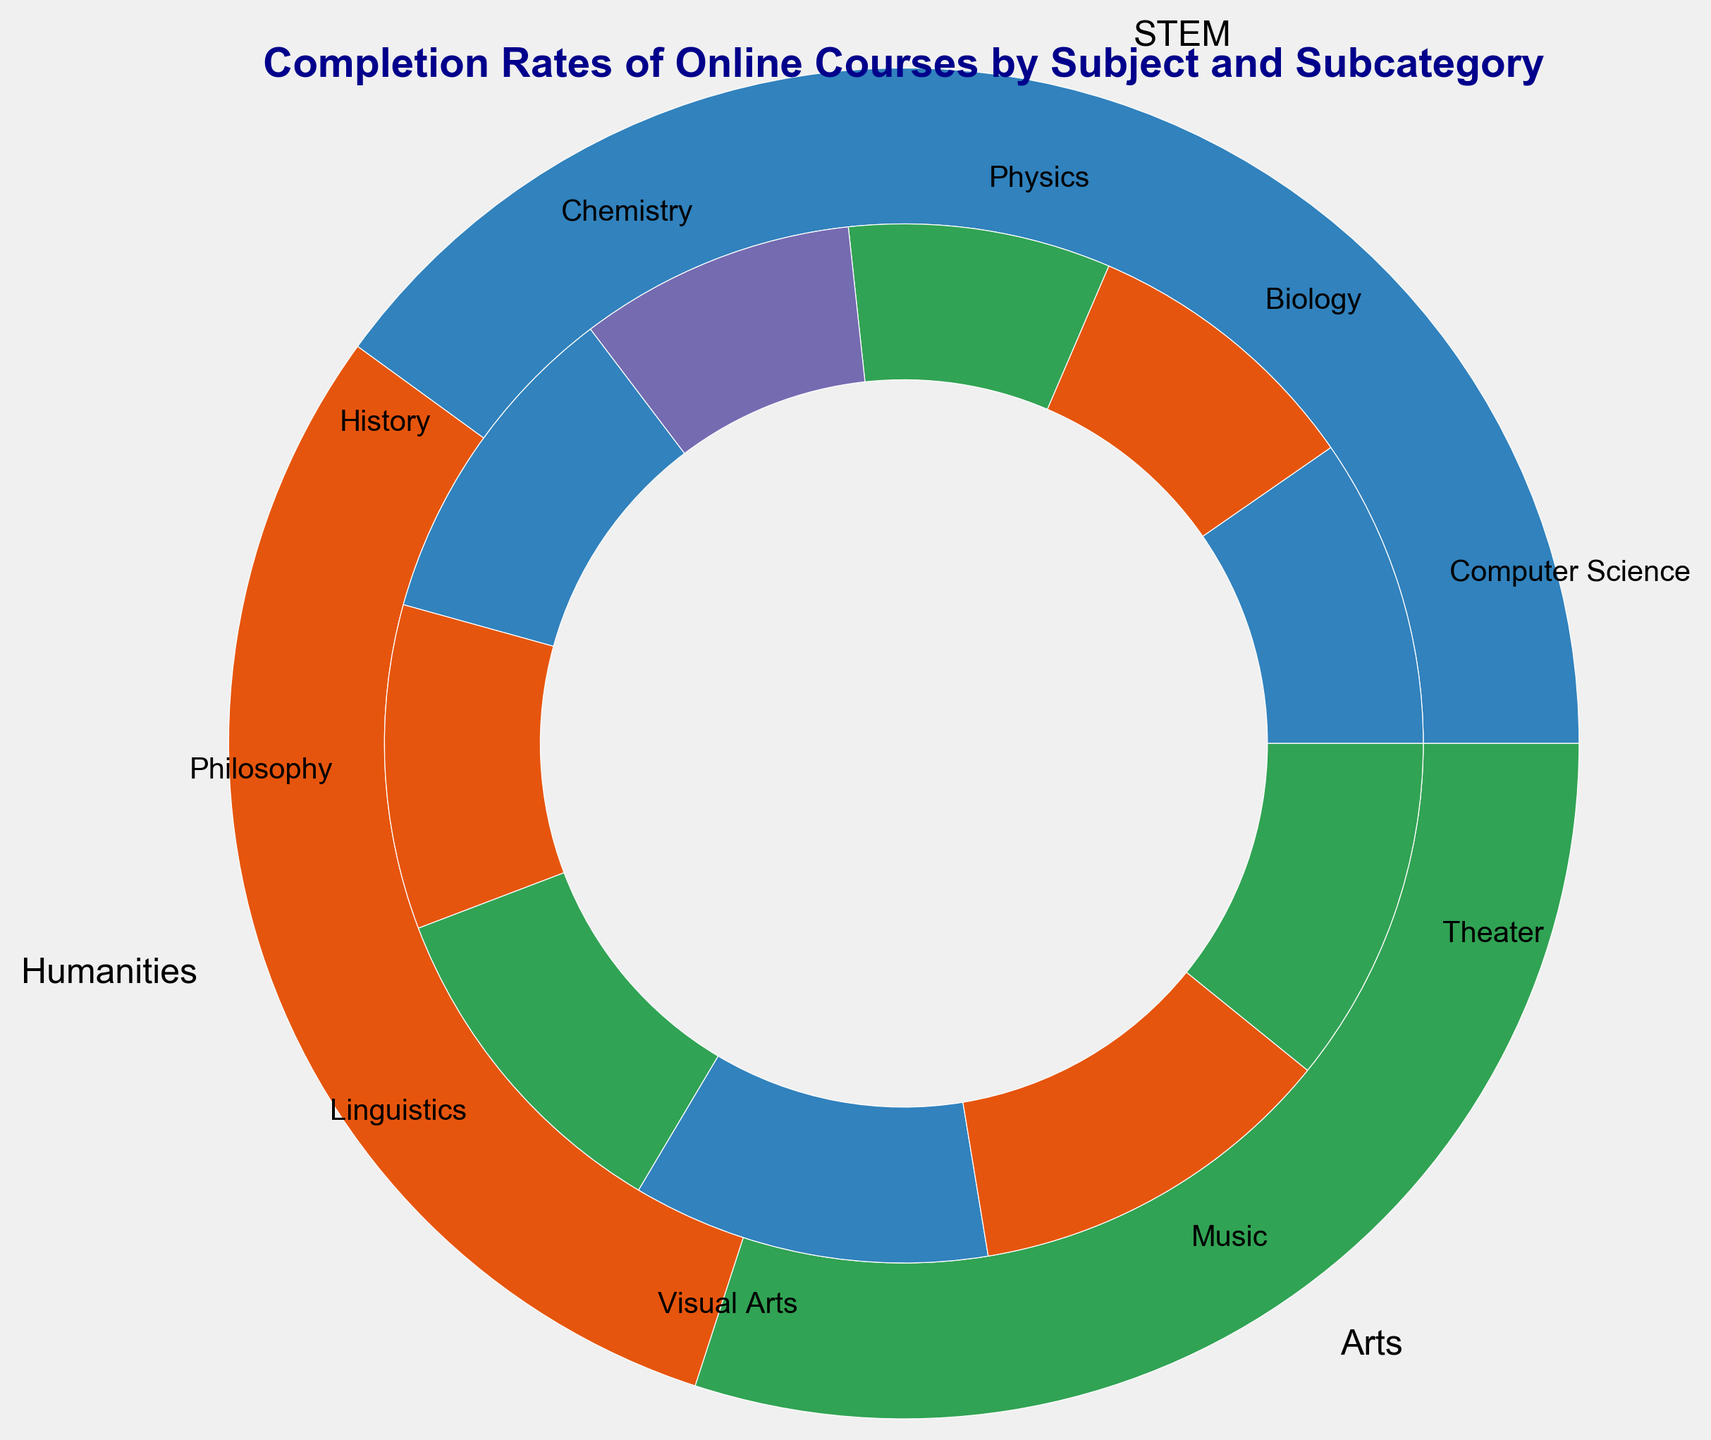Which subcategory under the Arts subject has the highest completion rate? Look at the inner pie segments within the Arts section; the largest segment will correspond to the highest completion rate. Music has the highest completion rate of 78%.
Answer: Music What is the completion rate difference between the Visual Arts and Theater subcategories? Identify the completion rates of Visual Arts (75%) and Theater (73%) from the inner pie segments. The completion rate difference is found by subtracting the rate of Theater from Visual Arts: 75% - 73% = 2%.
Answer: 2% Which has a higher completion rate, Computer Science or History? Compare the inner pie segments for Computer Science under STEM and History under Humanities. Computer Science has a completion rate of 65% and History has 70%, so History has the higher completion rate.
Answer: History What is the average completion rate of the Humanities subcategories? Identify the completion rates for History (70%), Philosophy (68%), and Linguistics (72%). Compute the average: (70% + 68% + 72%) / 3 = 70%.
Answer: 70% How many subcategories in STEM have completion rates above 60%? Look at the completion rates of each subcategory within STEM: Computer Science (65%), Biology (60%), Physics (55%), and Chemistry (58%). Only Computer Science has a rate above 60%.
Answer: 1 Which subject has the smallest number of subcategories? Examine the number of subcategories: STEM (4), Humanities (3), Arts (3). Both Humanities and Arts have the smallest number of subcategories with 3 each.
Answer: Humanities and Arts What is the combined completion rate of all subcategories within the Arts subject? Add up the completion rates for Visual Arts (75%), Music (78%), and Theater (73%): 75% + 78% + 73% = 226%.
Answer: 226% Which STEM subcategory has the lowest completion rate? Look for the smallest segment in STEM: Physics has the lowest completion rate of 55%.
Answer: Physics Compare completion rates between STEM and Humanities subjects; which one is greater on average? Compute the average for STEM (Computer Science 65%, Biology 60%, Physics 55%, Chemistry 58%): (65% + 60% + 55% + 58%) / 4 = 59.5%. Compute the average for Humanities (History 70%, Philosophy 68%, Linguistics 72%): (70% + 68% + 72%) / 3 = 70%. Humanities has a greater average completion rate.
Answer: Humanities 